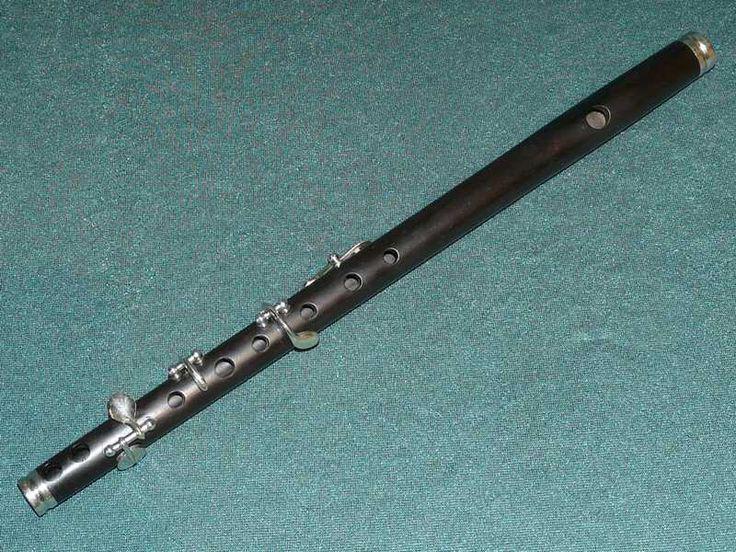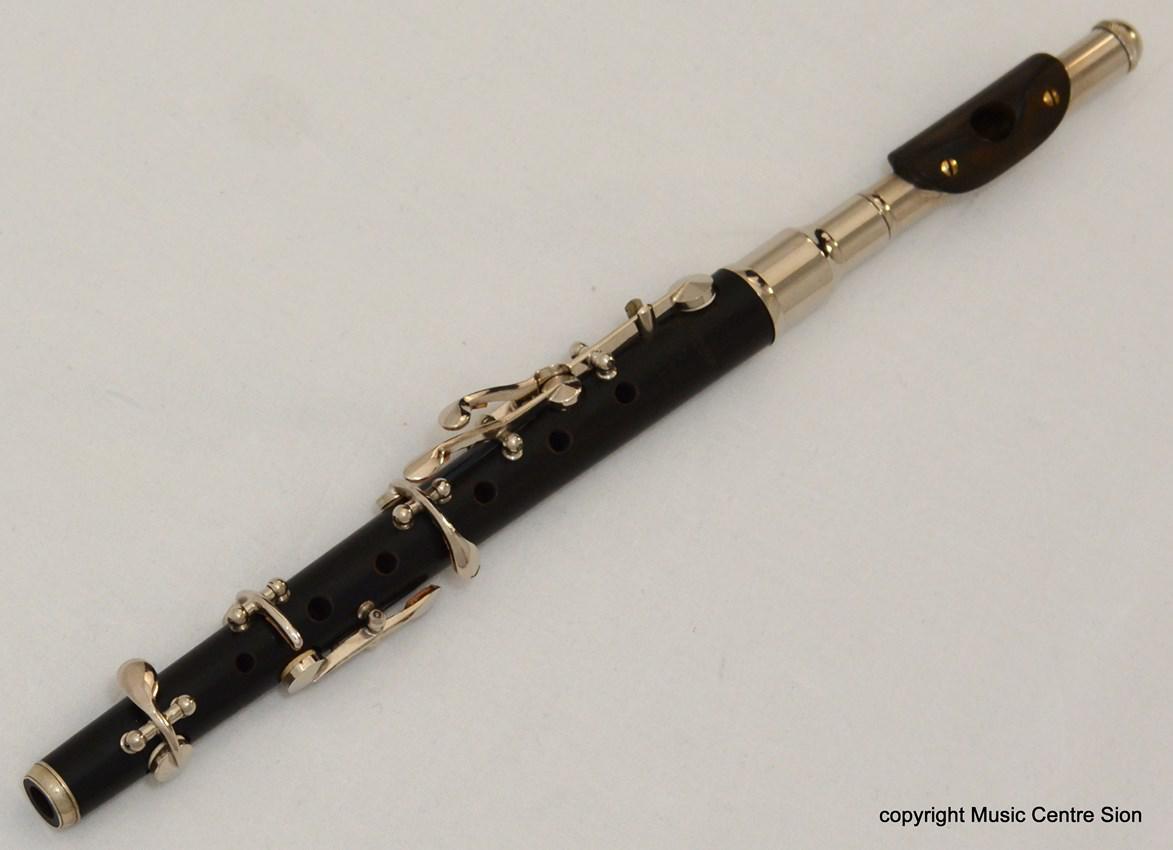The first image is the image on the left, the second image is the image on the right. Given the left and right images, does the statement "The left image contains a single flute displayed at an angle, and the right image includes one flute displayed at an angle opposite that of the flute on the left." hold true? Answer yes or no. No. The first image is the image on the left, the second image is the image on the right. Assess this claim about the two images: "The left and right image contains the same number of flutes.". Correct or not? Answer yes or no. Yes. 